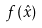Convert formula to latex. <formula><loc_0><loc_0><loc_500><loc_500>f ( \hat { x } )</formula> 